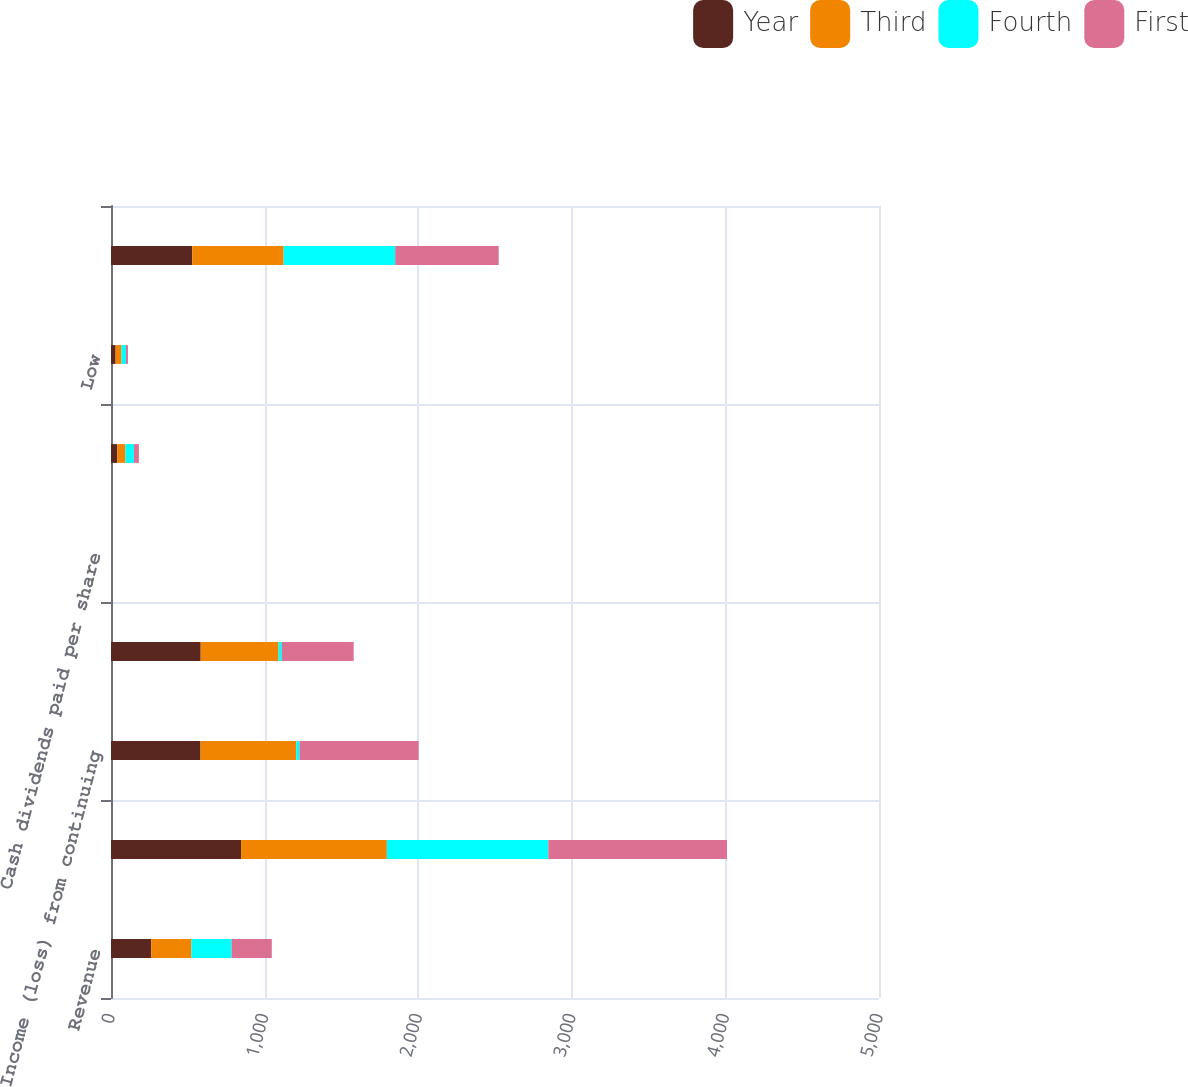<chart> <loc_0><loc_0><loc_500><loc_500><stacked_bar_chart><ecel><fcel>Revenue<fcel>Operating income<fcel>Income (loss) from continuing<fcel>Net income (loss)<fcel>Cash dividends paid per share<fcel>High<fcel>Low<fcel>Income from continuing<nl><fcel>Year<fcel>261.69<fcel>847<fcel>583<fcel>584<fcel>0.09<fcel>39.98<fcel>30<fcel>529<nl><fcel>Third<fcel>261.69<fcel>949<fcel>623<fcel>507<fcel>0.09<fcel>53.97<fcel>38.56<fcel>595<nl><fcel>Fourth<fcel>261.69<fcel>1051<fcel>21<fcel>21<fcel>0.09<fcel>55.38<fcel>29<fcel>726<nl><fcel>First<fcel>261.69<fcel>1163<fcel>776<fcel>468<fcel>0.09<fcel>32.09<fcel>12.8<fcel>674<nl></chart> 